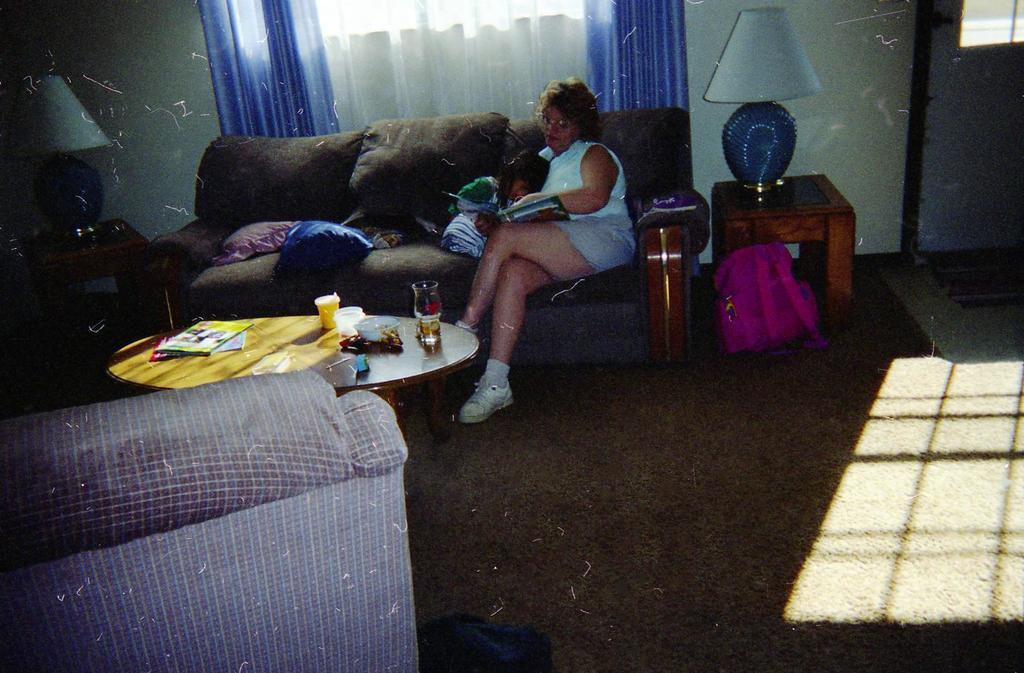Describe this image in one or two sentences. there is a lady sitting on the sofa and a baby sleeping in her lap behind her there is a lamp and a window curtains hanging. 